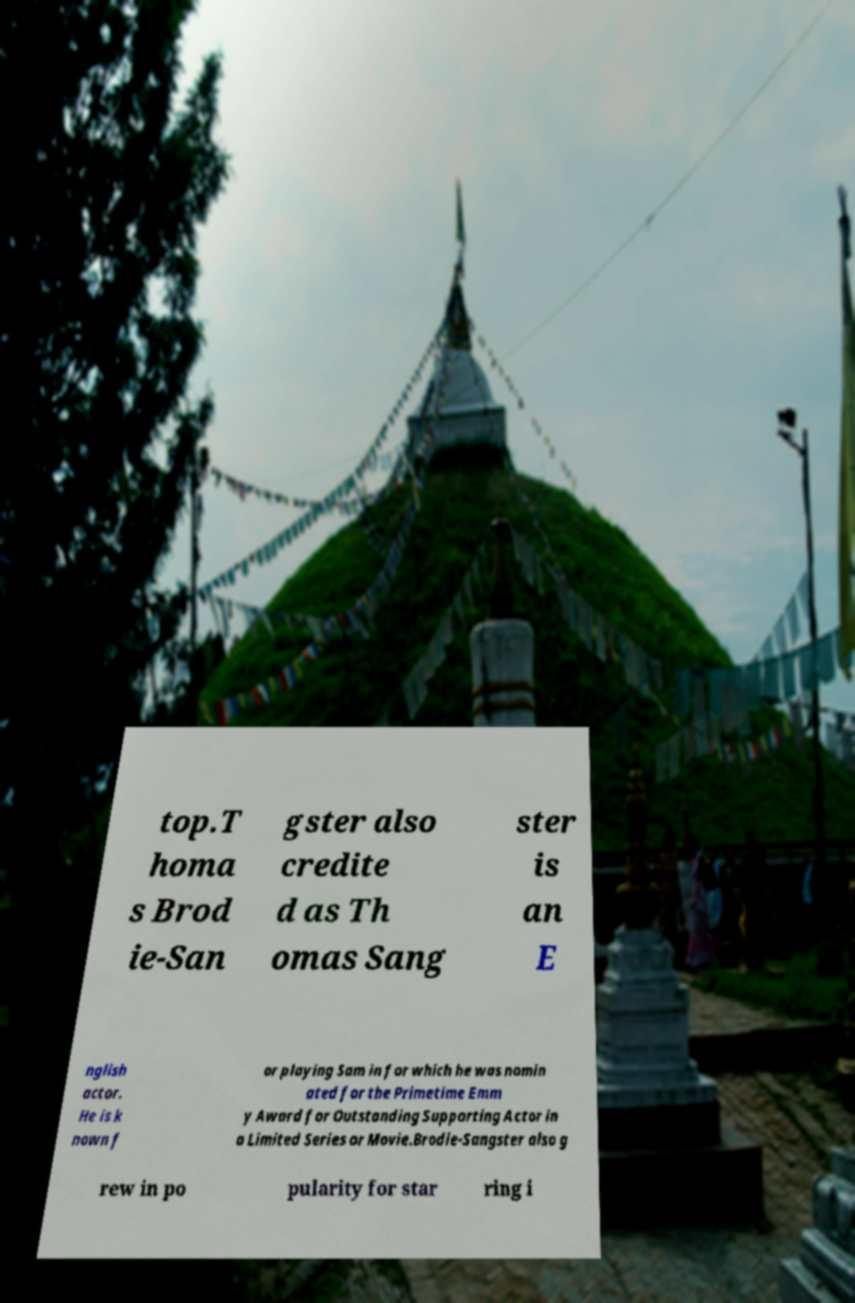Can you read and provide the text displayed in the image?This photo seems to have some interesting text. Can you extract and type it out for me? top.T homa s Brod ie-San gster also credite d as Th omas Sang ster is an E nglish actor. He is k nown f or playing Sam in for which he was nomin ated for the Primetime Emm y Award for Outstanding Supporting Actor in a Limited Series or Movie.Brodie-Sangster also g rew in po pularity for star ring i 